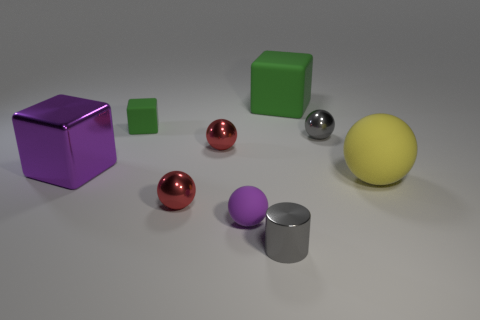Subtract all purple metal cubes. How many cubes are left? 2 Subtract all blue cubes. How many red balls are left? 2 Subtract all purple cubes. How many cubes are left? 2 Subtract all spheres. How many objects are left? 4 Subtract all brown cubes. Subtract all purple balls. How many cubes are left? 3 Add 7 big rubber objects. How many big rubber objects exist? 9 Subtract 1 purple cubes. How many objects are left? 8 Subtract all large matte things. Subtract all small green blocks. How many objects are left? 6 Add 4 large yellow rubber objects. How many large yellow rubber objects are left? 5 